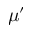<formula> <loc_0><loc_0><loc_500><loc_500>\mu ^ { \prime }</formula> 